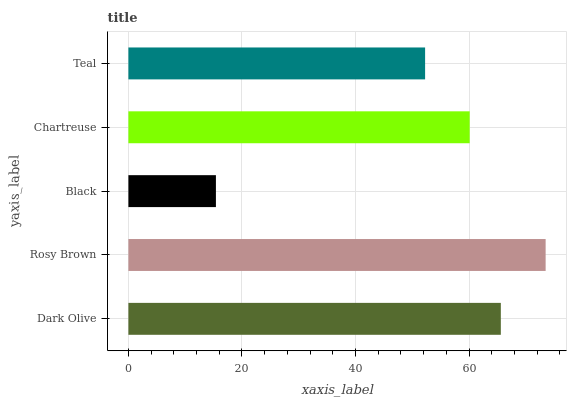Is Black the minimum?
Answer yes or no. Yes. Is Rosy Brown the maximum?
Answer yes or no. Yes. Is Rosy Brown the minimum?
Answer yes or no. No. Is Black the maximum?
Answer yes or no. No. Is Rosy Brown greater than Black?
Answer yes or no. Yes. Is Black less than Rosy Brown?
Answer yes or no. Yes. Is Black greater than Rosy Brown?
Answer yes or no. No. Is Rosy Brown less than Black?
Answer yes or no. No. Is Chartreuse the high median?
Answer yes or no. Yes. Is Chartreuse the low median?
Answer yes or no. Yes. Is Rosy Brown the high median?
Answer yes or no. No. Is Rosy Brown the low median?
Answer yes or no. No. 